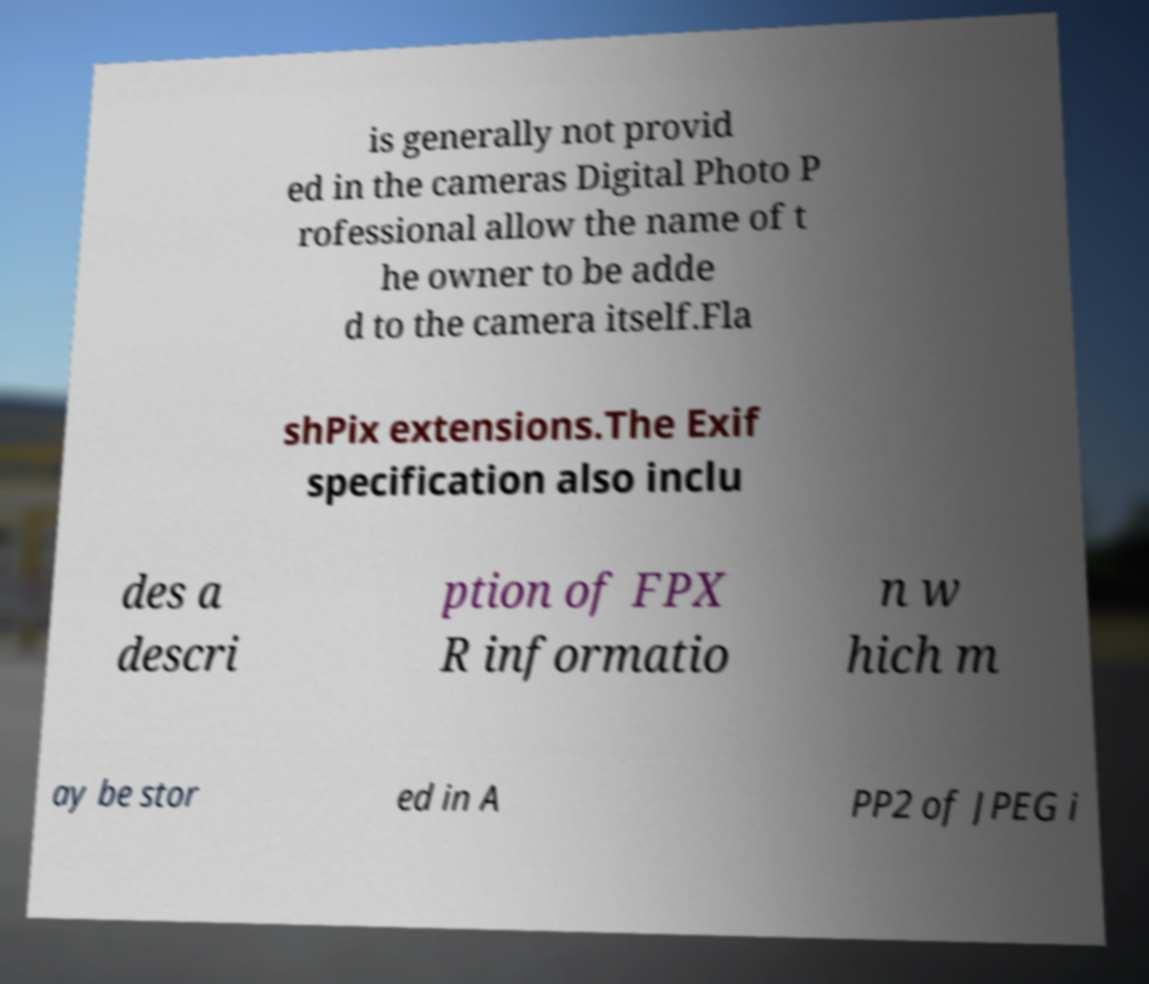I need the written content from this picture converted into text. Can you do that? is generally not provid ed in the cameras Digital Photo P rofessional allow the name of t he owner to be adde d to the camera itself.Fla shPix extensions.The Exif specification also inclu des a descri ption of FPX R informatio n w hich m ay be stor ed in A PP2 of JPEG i 